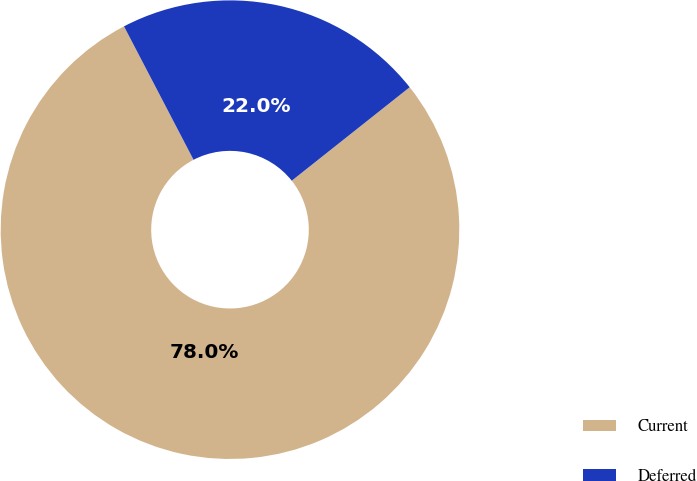<chart> <loc_0><loc_0><loc_500><loc_500><pie_chart><fcel>Current<fcel>Deferred<nl><fcel>78.02%<fcel>21.98%<nl></chart> 